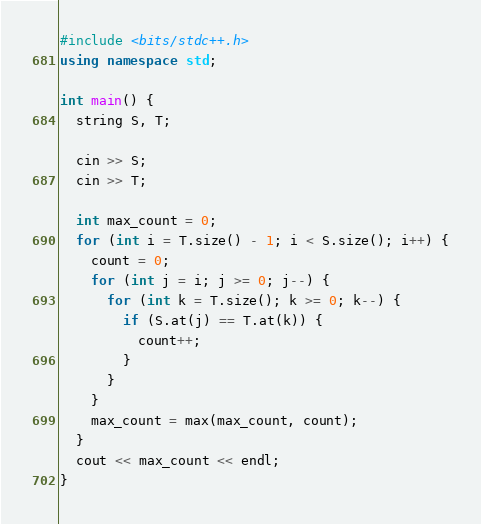<code> <loc_0><loc_0><loc_500><loc_500><_C++_>#include <bits/stdc++.h>
using namespace std;

int main() {
  string S, T;

  cin >> S;
  cin >> T;

  int max_count = 0;
  for (int i = T.size() - 1; i < S.size(); i++) {
    count = 0;
    for (int j = i; j >= 0; j--) {
      for (int k = T.size(); k >= 0; k--) {
        if (S.at(j) == T.at(k)) {
          count++;
        }
      }
    }
    max_count = max(max_count, count);
  }
  cout << max_count << endl;
}
</code> 